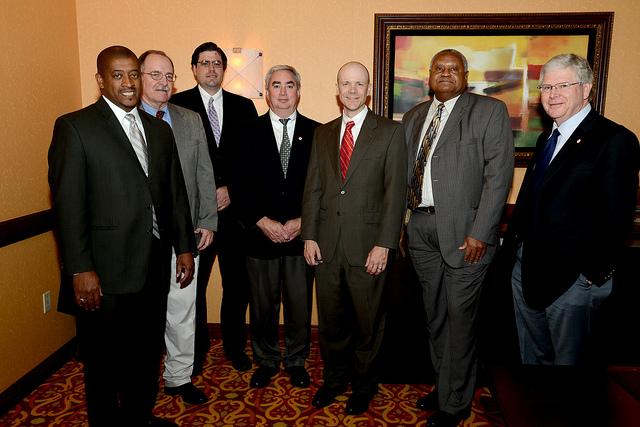How many men are wearing Khaki pants?
Write a very short answer. 1. How many people are holding a letter?
Short answer required. 0. How many ties are there?
Write a very short answer. 7. Is this a gym class?
Quick response, please. No. How many men are in the picture?
Concise answer only. 7. How many women are in the picture?
Answer briefly. 0. Are these adults?
Short answer required. Yes. 